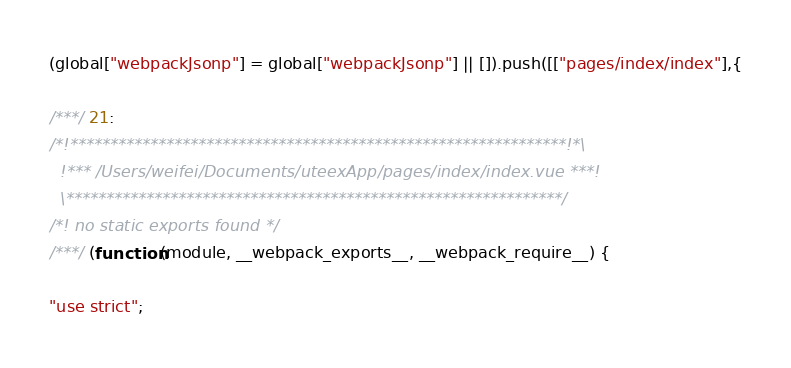Convert code to text. <code><loc_0><loc_0><loc_500><loc_500><_JavaScript_>(global["webpackJsonp"] = global["webpackJsonp"] || []).push([["pages/index/index"],{

/***/ 21:
/*!**************************************************************!*\
  !*** /Users/weifei/Documents/uteexApp/pages/index/index.vue ***!
  \**************************************************************/
/*! no static exports found */
/***/ (function(module, __webpack_exports__, __webpack_require__) {

"use strict";</code> 